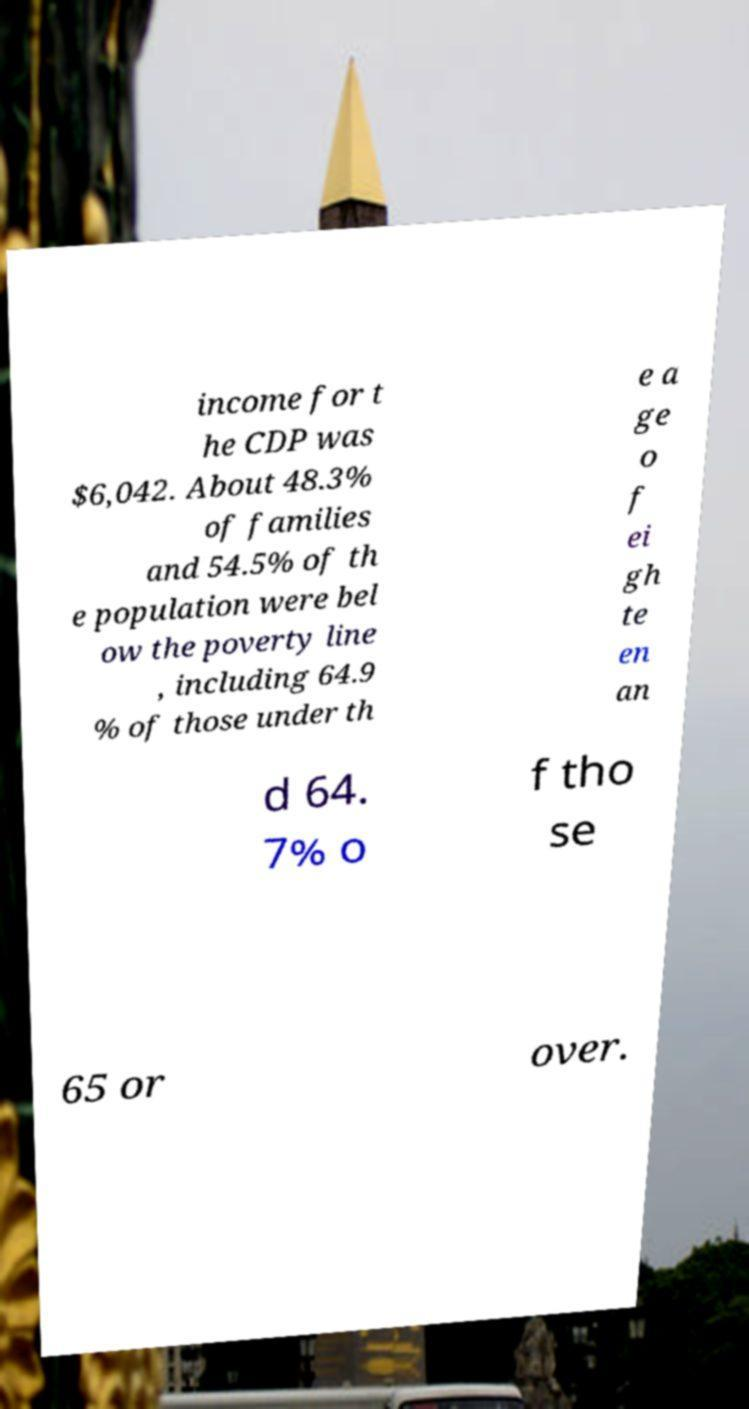Could you extract and type out the text from this image? income for t he CDP was $6,042. About 48.3% of families and 54.5% of th e population were bel ow the poverty line , including 64.9 % of those under th e a ge o f ei gh te en an d 64. 7% o f tho se 65 or over. 